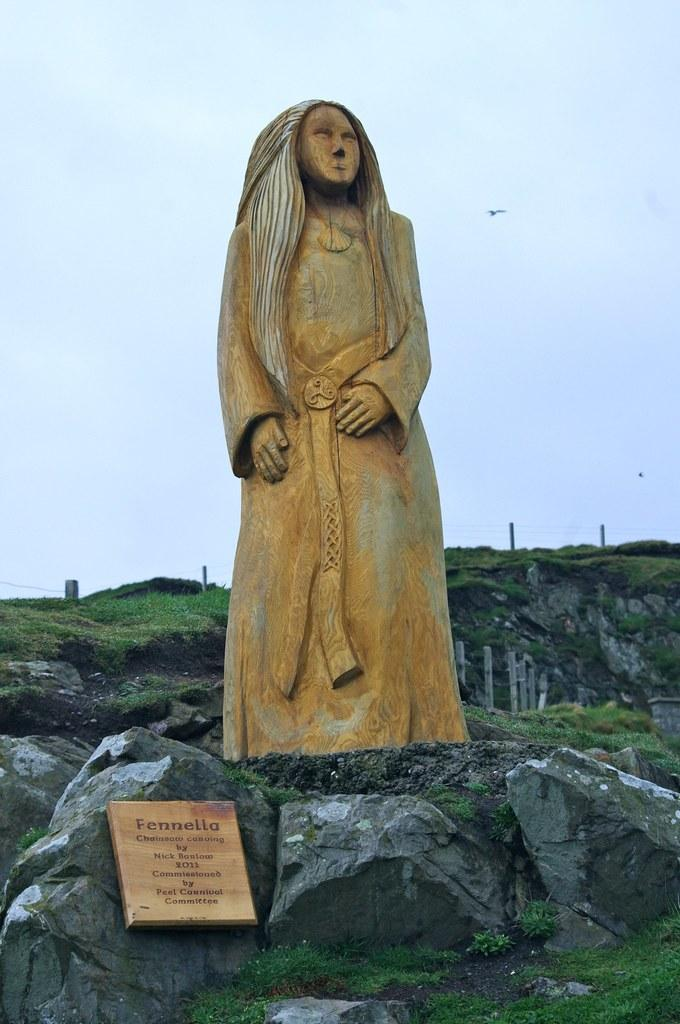What is the main subject of the image? The main subject of the image is a statue of a person. Where is the statue located? The statue is standing on a rock. What else can be seen in the image besides the statue? There is a grid with the word "Fenella" written on it in the image. How many chickens are present in the image? There are no chickens present in the image. What type of leather is used to make the statue's clothing? The statue is not a real person, so it does not have clothing made of leather or any other material. --- Facts: 1. There is a car in the image. 2. The car is parked on the street. 3. There are trees in the background of the image. 4. The sky is visible in the image. Absurd Topics: elephant, sand, volcano Conversation: What is the main subject of the image? The main subject of the image is a car. Where is the car located? The car is parked on the street. What can be seen in the background of the image? There are trees in the background of the image. What is visible at the top of the image? The sky is visible in the image. Reasoning: Let's think step by step in order to produce the conversation. We start by identifying the main subject of the image, which is the car. Then, we describe the car's location, which is parked on the street. Next, we mention the background elements, which are trees. Finally, we describe the sky's visibility at the top of the image. Each question is designed to elicit a specific detail about the image that is known from the provided facts. Absurd Question/Answer: Can you tell me how many elephants are standing near the car in the image? There are no elephants present in the image. What type of sand can be seen on the ground near the car in the image? There is no sand visible in the image; the car is parked on a street. 